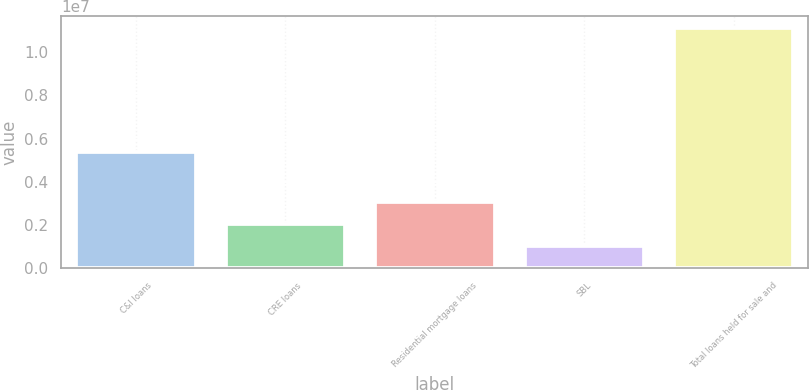<chart> <loc_0><loc_0><loc_500><loc_500><bar_chart><fcel>C&I loans<fcel>CRE loans<fcel>Residential mortgage loans<fcel>SBL<fcel>Total loans held for sale and<nl><fcel>5.37859e+06<fcel>2.03041e+06<fcel>3.03946e+06<fcel>1.02136e+06<fcel>1.11119e+07<nl></chart> 